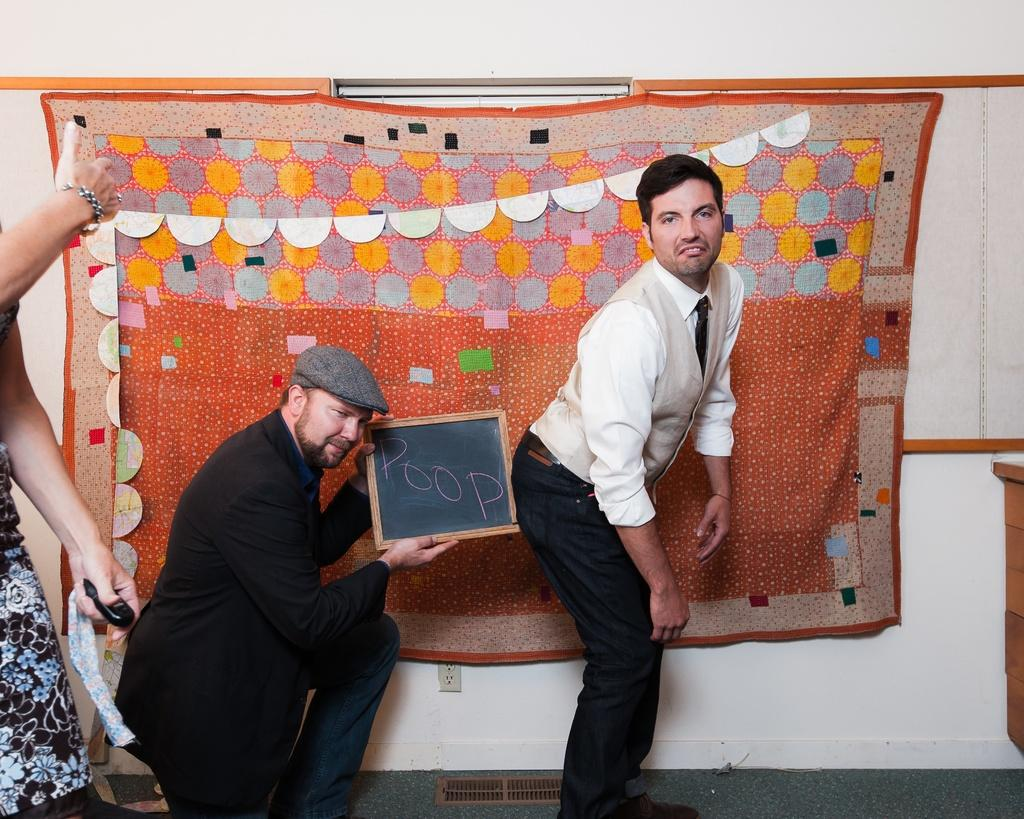What is the main subject of the image? There is a man standing in the image. What is the person holding in the image? There is a person holding a slate in the image. What can be seen in the background of the image? There is a curtain in the background of the image. What is the color of the wall in the image? There is a white color wall in the image. What attempt does the queen make in the image? There is no queen present in the image, so no such attempt can be observed. 